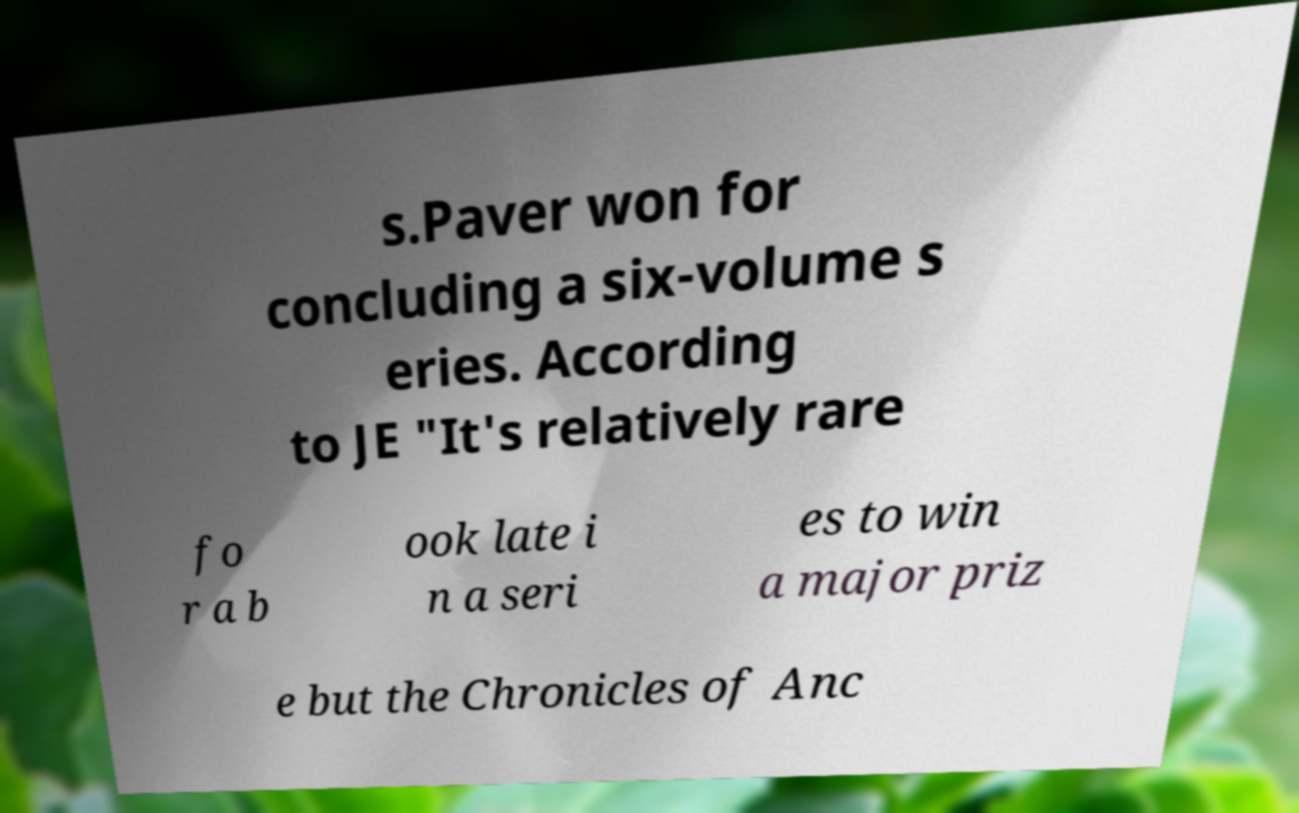I need the written content from this picture converted into text. Can you do that? s.Paver won for concluding a six-volume s eries. According to JE "It's relatively rare fo r a b ook late i n a seri es to win a major priz e but the Chronicles of Anc 